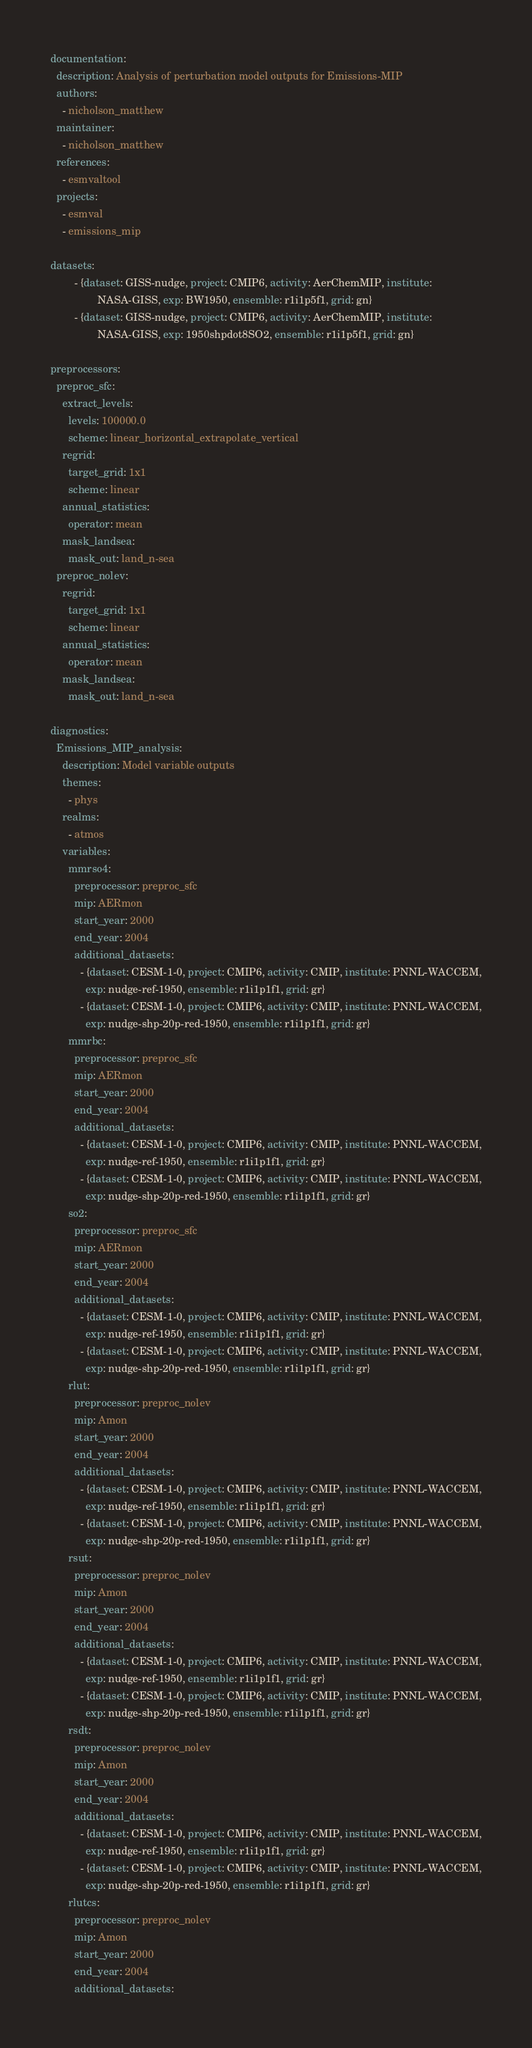<code> <loc_0><loc_0><loc_500><loc_500><_YAML_>documentation:
  description: Analysis of perturbation model outputs for Emissions-MIP
  authors:
    - nicholson_matthew
  maintainer:
    - nicholson_matthew
  references:
    - esmvaltool
  projects:
    - esmval
    - emissions_mip

datasets:
        - {dataset: GISS-nudge, project: CMIP6, activity: AerChemMIP, institute:
                NASA-GISS, exp: BW1950, ensemble: r1i1p5f1, grid: gn}
        - {dataset: GISS-nudge, project: CMIP6, activity: AerChemMIP, institute:
                NASA-GISS, exp: 1950shpdot8SO2, ensemble: r1i1p5f1, grid: gn}

preprocessors:
  preproc_sfc:
    extract_levels:
      levels: 100000.0
      scheme: linear_horizontal_extrapolate_vertical
    regrid:
      target_grid: 1x1
      scheme: linear
    annual_statistics:
      operator: mean
    mask_landsea:
      mask_out: land_n-sea
  preproc_nolev:
    regrid:
      target_grid: 1x1
      scheme: linear
    annual_statistics:
      operator: mean
    mask_landsea:
      mask_out: land_n-sea

diagnostics:
  Emissions_MIP_analysis:
    description: Model variable outputs
    themes:
      - phys
    realms:
      - atmos
    variables:
      mmrso4:
        preprocessor: preproc_sfc
        mip: AERmon
        start_year: 2000
        end_year: 2004
        additional_datasets:
          - {dataset: CESM-1-0, project: CMIP6, activity: CMIP, institute: PNNL-WACCEM,
            exp: nudge-ref-1950, ensemble: r1i1p1f1, grid: gr}
          - {dataset: CESM-1-0, project: CMIP6, activity: CMIP, institute: PNNL-WACCEM,
            exp: nudge-shp-20p-red-1950, ensemble: r1i1p1f1, grid: gr}
      mmrbc:
        preprocessor: preproc_sfc
        mip: AERmon
        start_year: 2000
        end_year: 2004
        additional_datasets:
          - {dataset: CESM-1-0, project: CMIP6, activity: CMIP, institute: PNNL-WACCEM,
            exp: nudge-ref-1950, ensemble: r1i1p1f1, grid: gr}
          - {dataset: CESM-1-0, project: CMIP6, activity: CMIP, institute: PNNL-WACCEM,
            exp: nudge-shp-20p-red-1950, ensemble: r1i1p1f1, grid: gr}
      so2:
        preprocessor: preproc_sfc
        mip: AERmon
        start_year: 2000
        end_year: 2004
        additional_datasets:
          - {dataset: CESM-1-0, project: CMIP6, activity: CMIP, institute: PNNL-WACCEM,
            exp: nudge-ref-1950, ensemble: r1i1p1f1, grid: gr}
          - {dataset: CESM-1-0, project: CMIP6, activity: CMIP, institute: PNNL-WACCEM,
            exp: nudge-shp-20p-red-1950, ensemble: r1i1p1f1, grid: gr}
      rlut:
        preprocessor: preproc_nolev
        mip: Amon
        start_year: 2000
        end_year: 2004
        additional_datasets:
          - {dataset: CESM-1-0, project: CMIP6, activity: CMIP, institute: PNNL-WACCEM,
            exp: nudge-ref-1950, ensemble: r1i1p1f1, grid: gr}
          - {dataset: CESM-1-0, project: CMIP6, activity: CMIP, institute: PNNL-WACCEM,
            exp: nudge-shp-20p-red-1950, ensemble: r1i1p1f1, grid: gr}
      rsut:
        preprocessor: preproc_nolev
        mip: Amon
        start_year: 2000
        end_year: 2004
        additional_datasets:
          - {dataset: CESM-1-0, project: CMIP6, activity: CMIP, institute: PNNL-WACCEM,
            exp: nudge-ref-1950, ensemble: r1i1p1f1, grid: gr}
          - {dataset: CESM-1-0, project: CMIP6, activity: CMIP, institute: PNNL-WACCEM,
            exp: nudge-shp-20p-red-1950, ensemble: r1i1p1f1, grid: gr}
      rsdt:
        preprocessor: preproc_nolev
        mip: Amon
        start_year: 2000
        end_year: 2004
        additional_datasets:
          - {dataset: CESM-1-0, project: CMIP6, activity: CMIP, institute: PNNL-WACCEM,
            exp: nudge-ref-1950, ensemble: r1i1p1f1, grid: gr}
          - {dataset: CESM-1-0, project: CMIP6, activity: CMIP, institute: PNNL-WACCEM,
            exp: nudge-shp-20p-red-1950, ensemble: r1i1p1f1, grid: gr}
      rlutcs:
        preprocessor: preproc_nolev
        mip: Amon
        start_year: 2000
        end_year: 2004
        additional_datasets:</code> 